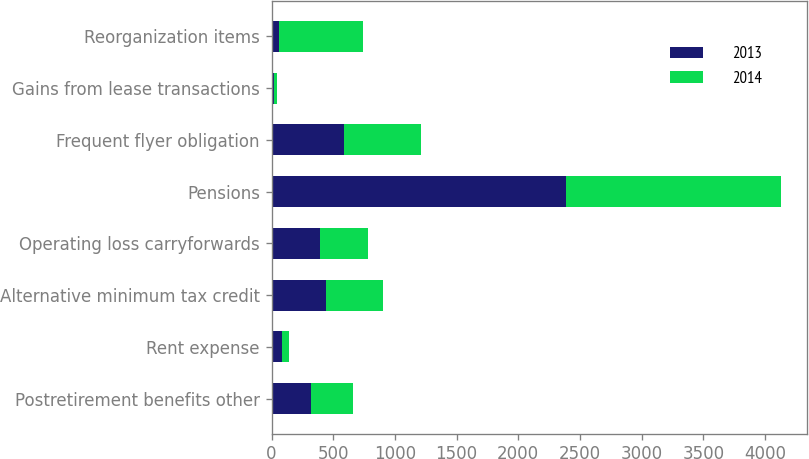Convert chart to OTSL. <chart><loc_0><loc_0><loc_500><loc_500><stacked_bar_chart><ecel><fcel>Postretirement benefits other<fcel>Rent expense<fcel>Alternative minimum tax credit<fcel>Operating loss carryforwards<fcel>Pensions<fcel>Frequent flyer obligation<fcel>Gains from lease transactions<fcel>Reorganization items<nl><fcel>2013<fcel>322<fcel>86<fcel>438<fcel>390<fcel>2385<fcel>589<fcel>22<fcel>64<nl><fcel>2014<fcel>342<fcel>55<fcel>467<fcel>390<fcel>1747<fcel>620<fcel>24<fcel>675<nl></chart> 